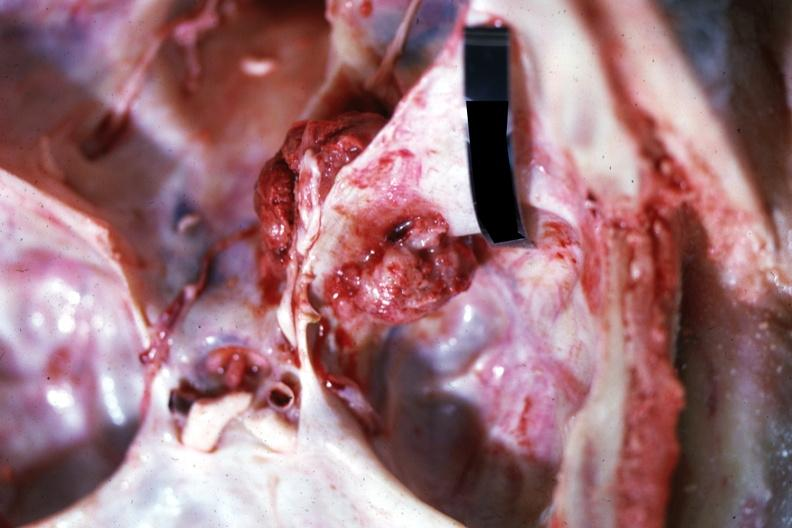s bone, skull present?
Answer the question using a single word or phrase. Yes 